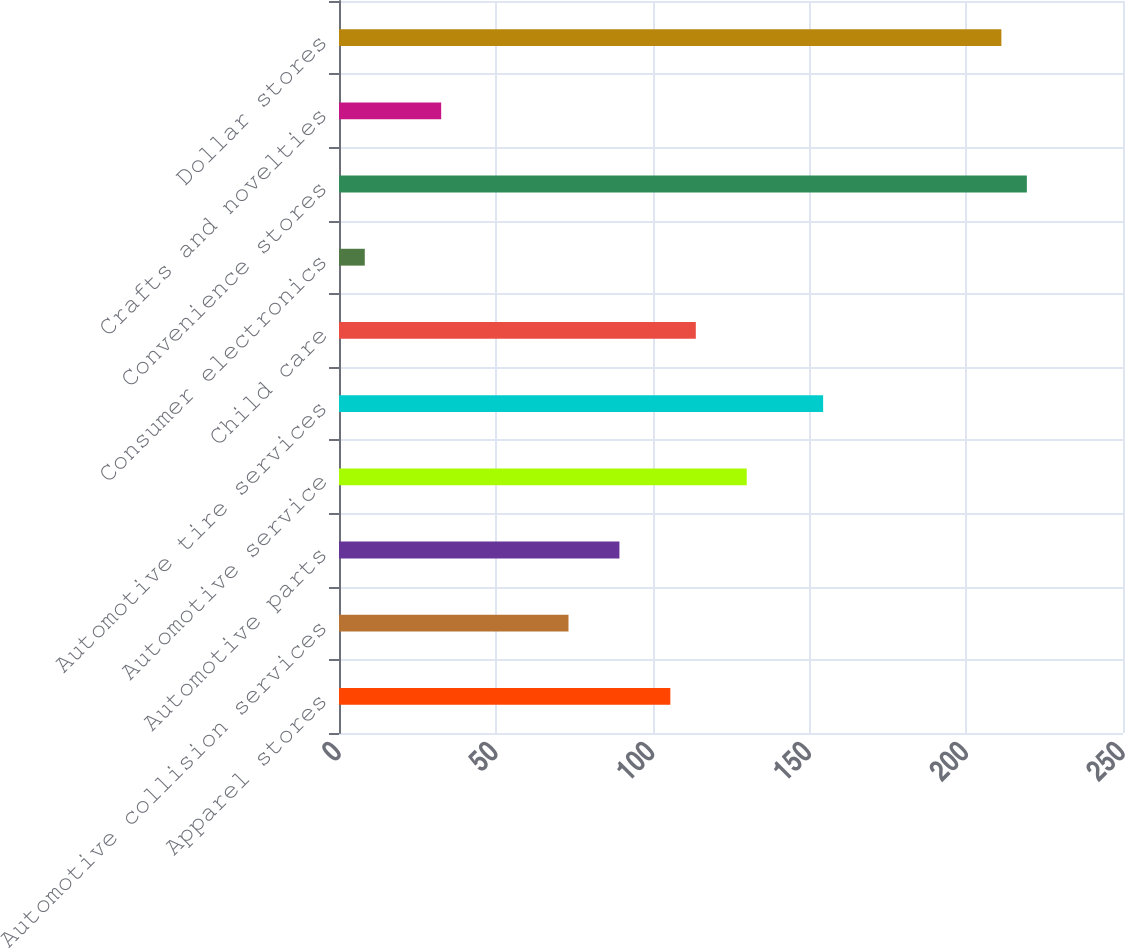Convert chart to OTSL. <chart><loc_0><loc_0><loc_500><loc_500><bar_chart><fcel>Apparel stores<fcel>Automotive collision services<fcel>Automotive parts<fcel>Automotive service<fcel>Automotive tire services<fcel>Child care<fcel>Consumer electronics<fcel>Convenience stores<fcel>Crafts and novelties<fcel>Dollar stores<nl><fcel>105.66<fcel>73.18<fcel>89.42<fcel>130.02<fcel>154.38<fcel>113.78<fcel>8.22<fcel>219.34<fcel>32.58<fcel>211.22<nl></chart> 